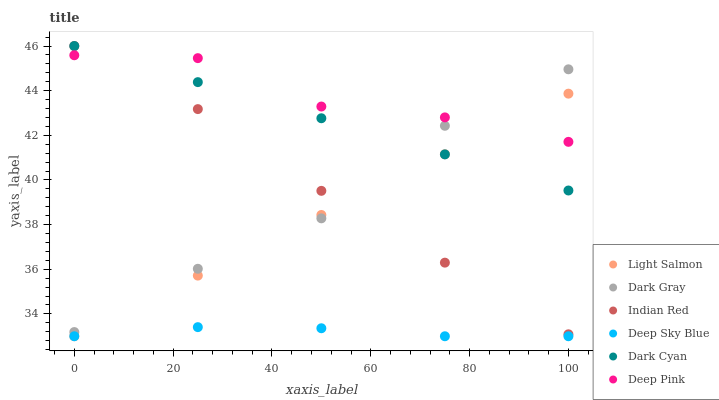Does Deep Sky Blue have the minimum area under the curve?
Answer yes or no. Yes. Does Deep Pink have the maximum area under the curve?
Answer yes or no. Yes. Does Indian Red have the minimum area under the curve?
Answer yes or no. No. Does Indian Red have the maximum area under the curve?
Answer yes or no. No. Is Dark Cyan the smoothest?
Answer yes or no. Yes. Is Deep Pink the roughest?
Answer yes or no. Yes. Is Indian Red the smoothest?
Answer yes or no. No. Is Indian Red the roughest?
Answer yes or no. No. Does Light Salmon have the lowest value?
Answer yes or no. Yes. Does Indian Red have the lowest value?
Answer yes or no. No. Does Dark Cyan have the highest value?
Answer yes or no. Yes. Does Deep Pink have the highest value?
Answer yes or no. No. Is Deep Sky Blue less than Deep Pink?
Answer yes or no. Yes. Is Indian Red greater than Deep Sky Blue?
Answer yes or no. Yes. Does Dark Cyan intersect Dark Gray?
Answer yes or no. Yes. Is Dark Cyan less than Dark Gray?
Answer yes or no. No. Is Dark Cyan greater than Dark Gray?
Answer yes or no. No. Does Deep Sky Blue intersect Deep Pink?
Answer yes or no. No. 